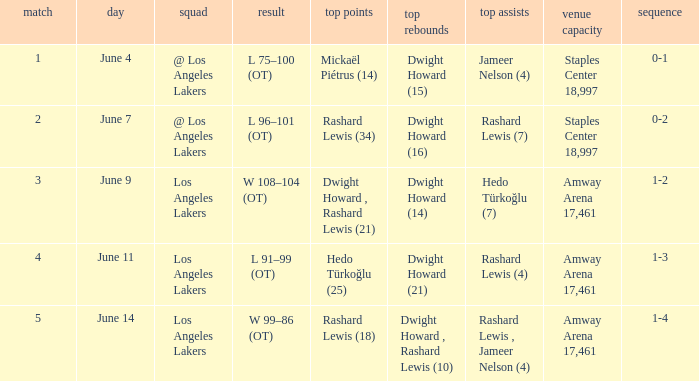What is the highest Game, when High Assists is "Hedo Türkoğlu (7)"? 3.0. 